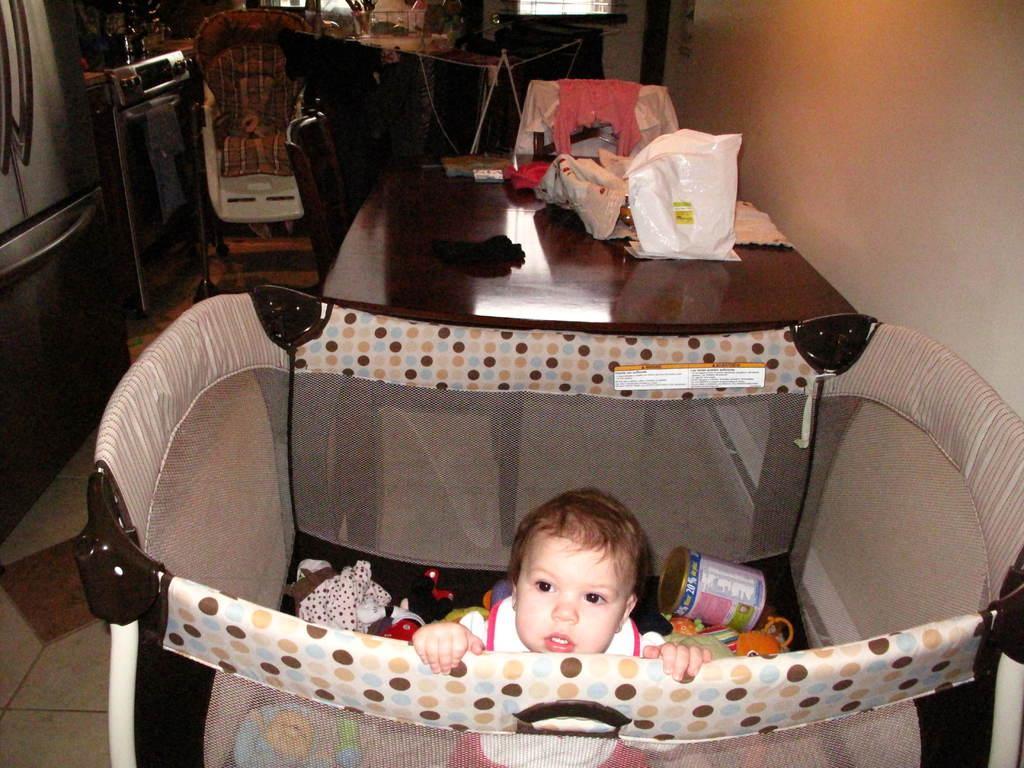Can you describe this image briefly? A baby is inside a box. There are many toys in it. And there is a table on the table there are many objects like cloth, covers. And to the left side there is a refrigerator. Beside the refrigerator there is a oven. We can see a stroller. And on the floor there is a floor mat. 